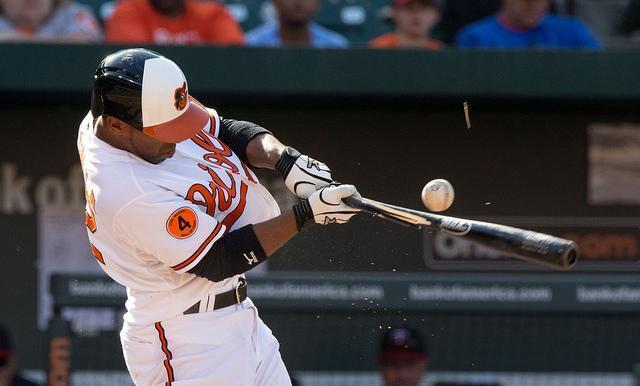How many people are in the photo?
Give a very brief answer. 7. 